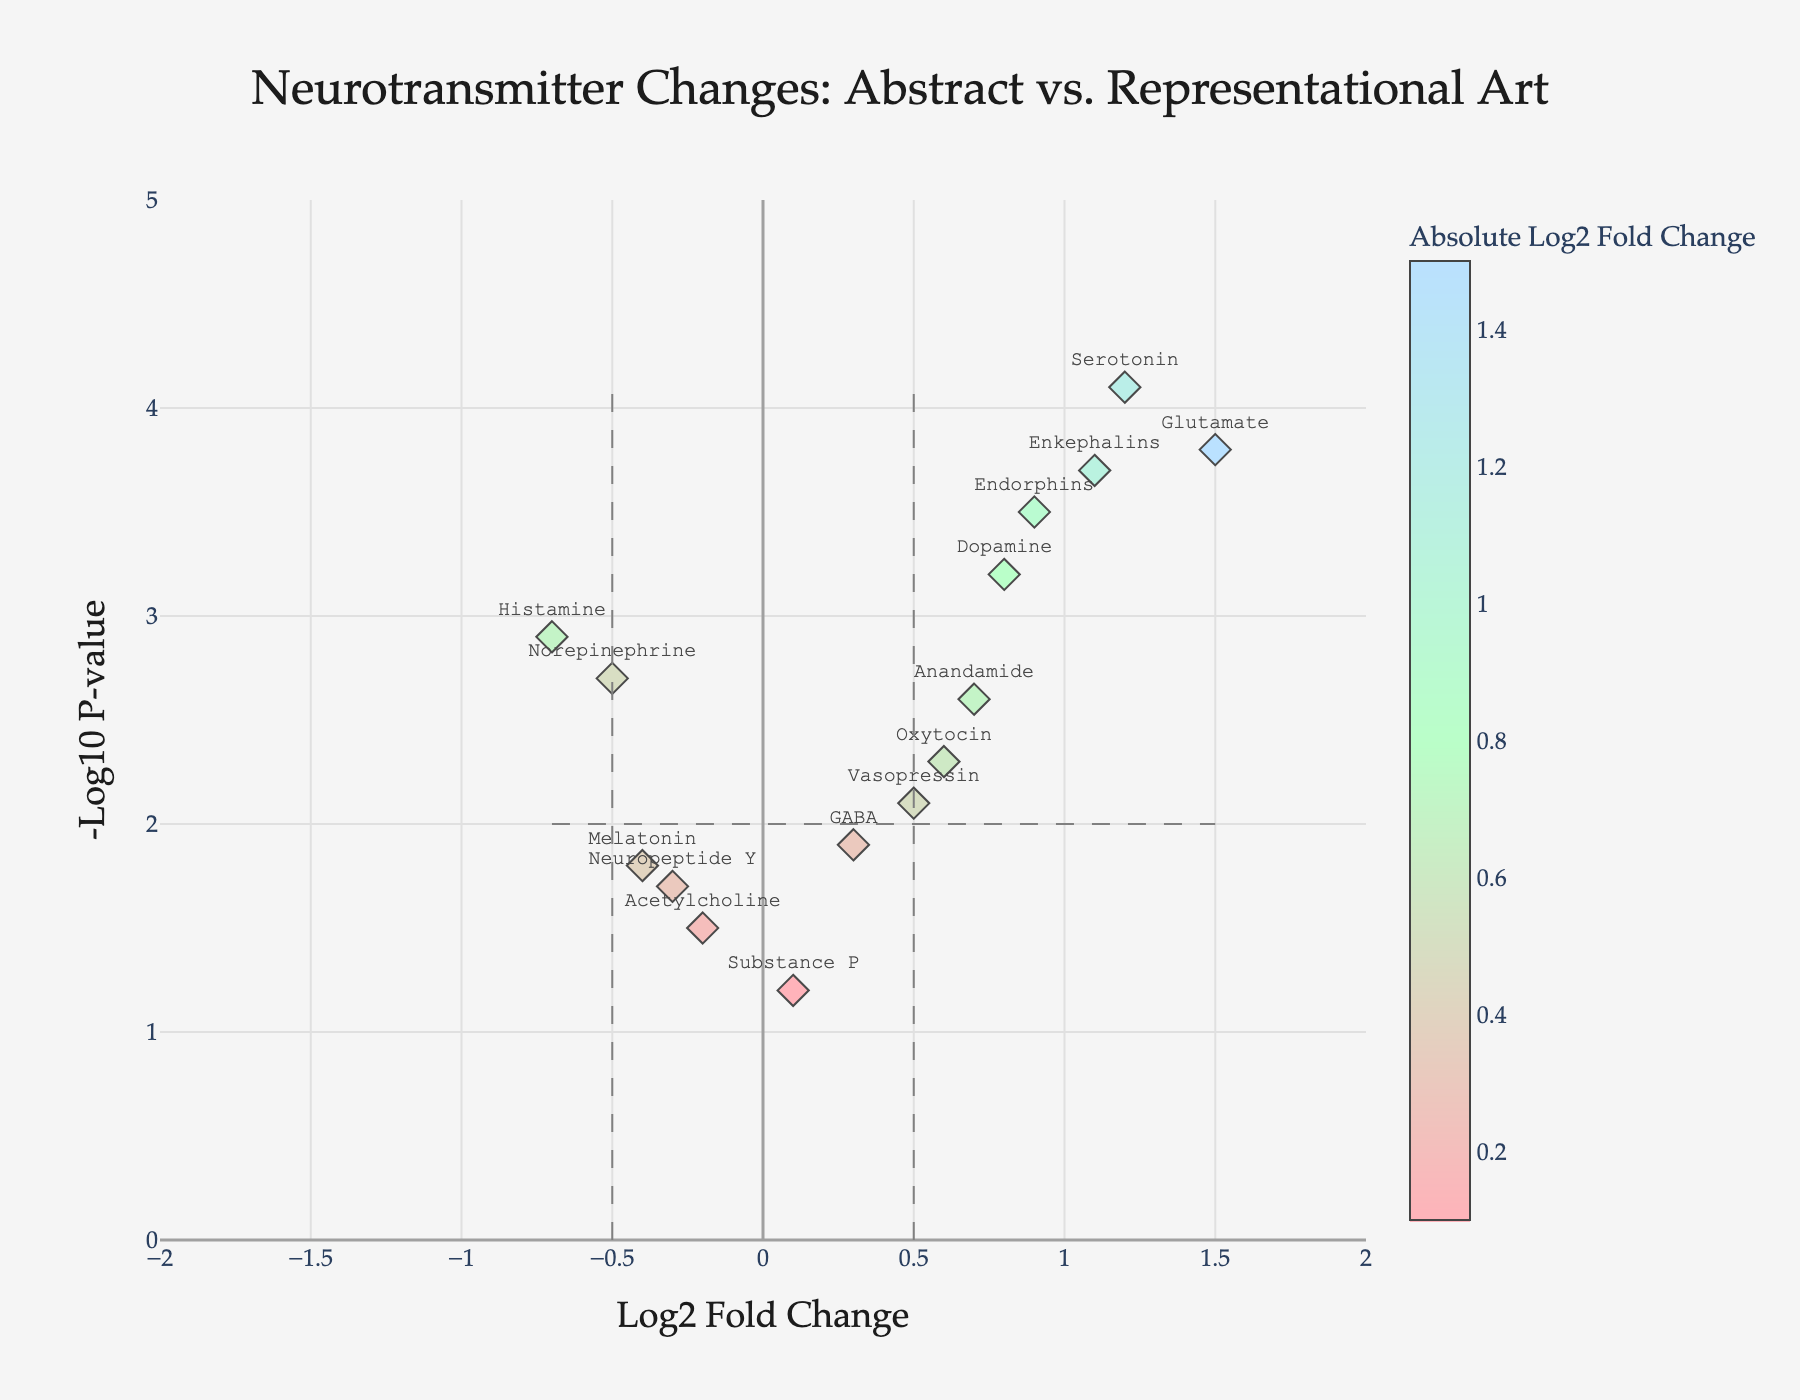What is the title of the figure? The title is at the top center of the figure in bold text. It reads "Neurotransmitter Changes: Abstract vs. Representational Art".
Answer: Neurotransmitter Changes: Abstract vs. Representational Art What are the labels of the x and y axes? The x-axis title is "Log2 Fold Change", and the y-axis title is "-Log10 P-value". Both titles are in a distinct font and clearly displayed.
Answer: Log2 Fold Change; -Log10 P-value How many data points have a negative Log2 Fold Change value? There are five data points (Norepinephrine, Acetylcholine, Melatonin, Histamine, Neuropeptide Y) on the left side of the zero line on the x-axis, indicating negative Log2 Fold Change values.
Answer: Five Which neurotransmitter has the highest -Log10 P-value? The neurotransmitter with the highest -Log10 P-value is positioned at the highest point along the y-axis, which is Serotonin with a value of 4.1.
Answer: Serotonin Which neurotransmitter has the highest positive Log2 Fold Change? The neurotransmitter with the highest positive Log2 Fold Change appears farthest to the right on the x-axis, which is Glutamate with a Log2 Fold Change of 1.5.
Answer: Glutamate Which neurotransmitter has a Log2 Fold Change closest to zero? The neurotransmitter with a Log2 Fold Change closest to the zero line on the x-axis is Substance P, with a value of 0.1.
Answer: Substance P How many neurotransmitters have -Log10 P-value values greater than or equal to 3? To identify the data points with -Log10 P-value values equal to or greater than 3, count the points above the horizontal threshold line at the y-axis value of 3. The neurotransmitters are Dopamine, Serotonin, Glutamate, Endorphins, Enkephalins, and Histamine.
Answer: Six What are the upper-bound and lower-bound values for the x-axis range? The x-axis range is displayed at the bottom, with the lower bound at -2 and the upper bound at 2.
Answer: -2; 2 Which neurotransmitter has the largest decrease (negative) in Log2 Fold Change value? Among the negative Log2 Fold Change values, the neurotransmitter with the lowest point to the left of the zero line on the x-axis is Histamine, with a value of -0.7.
Answer: Histamine Which two neurotransmitters have nearly equal Log2 Fold Change values but different -Log10 P-values? Oxytocin and Vasopressin have nearly equal Log2 Fold Change values at 0.6 and 0.5 respectively, but differ in their -Log10 P-values with 2.3 for Oxytocin and 2.1 for Vasopressin.
Answer: Oxytocin and Vasopressin 